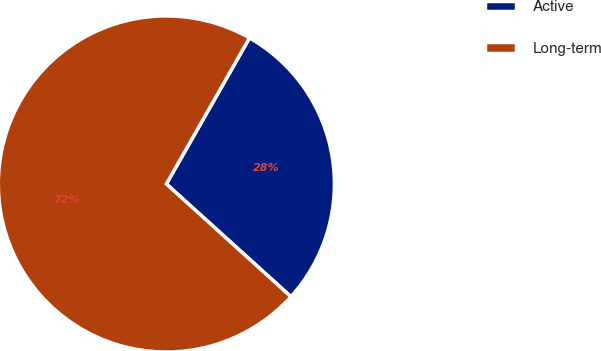<chart> <loc_0><loc_0><loc_500><loc_500><pie_chart><fcel>Active<fcel>Long-term<nl><fcel>28.47%<fcel>71.53%<nl></chart> 